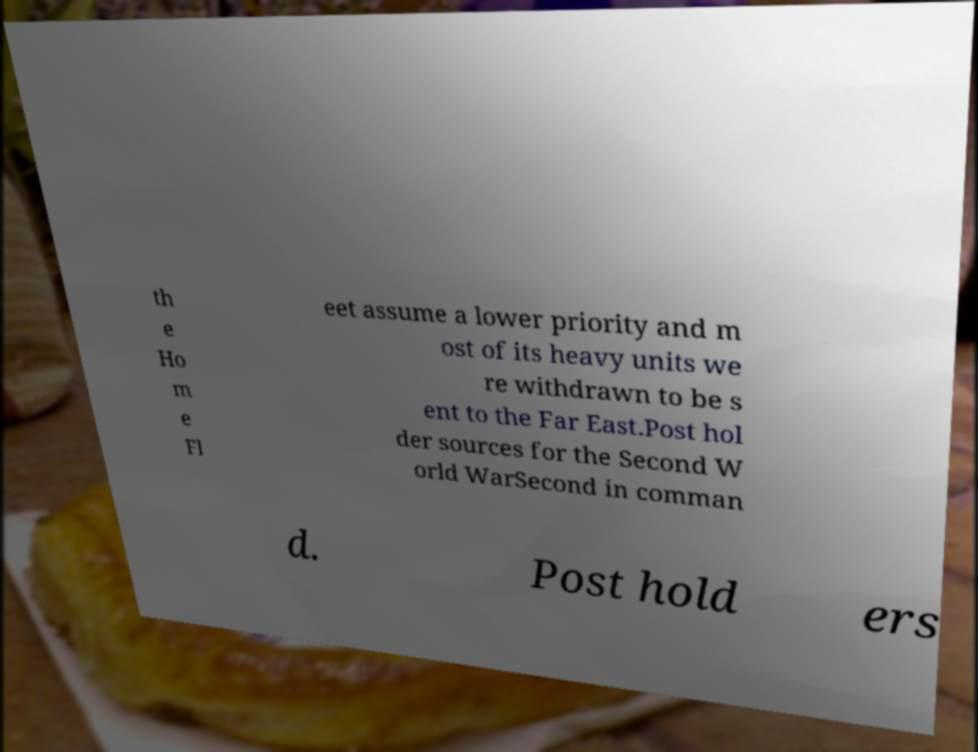There's text embedded in this image that I need extracted. Can you transcribe it verbatim? th e Ho m e Fl eet assume a lower priority and m ost of its heavy units we re withdrawn to be s ent to the Far East.Post hol der sources for the Second W orld WarSecond in comman d. Post hold ers 